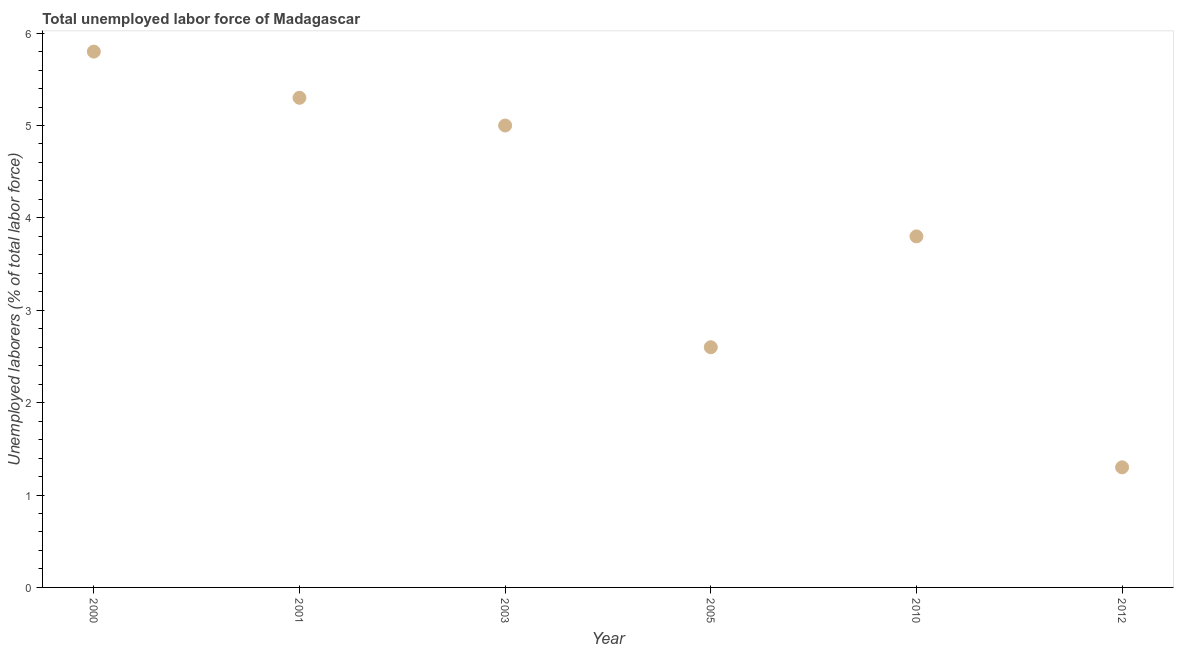What is the total unemployed labour force in 2010?
Provide a short and direct response. 3.8. Across all years, what is the maximum total unemployed labour force?
Provide a succinct answer. 5.8. Across all years, what is the minimum total unemployed labour force?
Offer a very short reply. 1.3. What is the sum of the total unemployed labour force?
Your answer should be compact. 23.8. What is the difference between the total unemployed labour force in 2000 and 2005?
Provide a succinct answer. 3.2. What is the average total unemployed labour force per year?
Keep it short and to the point. 3.97. What is the median total unemployed labour force?
Your answer should be very brief. 4.4. What is the ratio of the total unemployed labour force in 2001 to that in 2003?
Offer a very short reply. 1.06. Is the total unemployed labour force in 2000 less than that in 2003?
Provide a short and direct response. No. Is the difference between the total unemployed labour force in 2010 and 2012 greater than the difference between any two years?
Offer a very short reply. No. What is the difference between the highest and the second highest total unemployed labour force?
Your answer should be very brief. 0.5. What is the difference between the highest and the lowest total unemployed labour force?
Make the answer very short. 4.5. How many dotlines are there?
Provide a short and direct response. 1. What is the difference between two consecutive major ticks on the Y-axis?
Keep it short and to the point. 1. Does the graph contain any zero values?
Offer a terse response. No. What is the title of the graph?
Your response must be concise. Total unemployed labor force of Madagascar. What is the label or title of the Y-axis?
Ensure brevity in your answer.  Unemployed laborers (% of total labor force). What is the Unemployed laborers (% of total labor force) in 2000?
Offer a very short reply. 5.8. What is the Unemployed laborers (% of total labor force) in 2001?
Provide a succinct answer. 5.3. What is the Unemployed laborers (% of total labor force) in 2003?
Make the answer very short. 5. What is the Unemployed laborers (% of total labor force) in 2005?
Offer a very short reply. 2.6. What is the Unemployed laborers (% of total labor force) in 2010?
Ensure brevity in your answer.  3.8. What is the Unemployed laborers (% of total labor force) in 2012?
Offer a very short reply. 1.3. What is the difference between the Unemployed laborers (% of total labor force) in 2000 and 2001?
Give a very brief answer. 0.5. What is the difference between the Unemployed laborers (% of total labor force) in 2000 and 2003?
Ensure brevity in your answer.  0.8. What is the difference between the Unemployed laborers (% of total labor force) in 2000 and 2005?
Your answer should be compact. 3.2. What is the difference between the Unemployed laborers (% of total labor force) in 2000 and 2010?
Your answer should be very brief. 2. What is the difference between the Unemployed laborers (% of total labor force) in 2001 and 2003?
Provide a succinct answer. 0.3. What is the difference between the Unemployed laborers (% of total labor force) in 2001 and 2012?
Make the answer very short. 4. What is the difference between the Unemployed laborers (% of total labor force) in 2003 and 2012?
Offer a terse response. 3.7. What is the difference between the Unemployed laborers (% of total labor force) in 2005 and 2010?
Offer a very short reply. -1.2. What is the difference between the Unemployed laborers (% of total labor force) in 2005 and 2012?
Keep it short and to the point. 1.3. What is the ratio of the Unemployed laborers (% of total labor force) in 2000 to that in 2001?
Give a very brief answer. 1.09. What is the ratio of the Unemployed laborers (% of total labor force) in 2000 to that in 2003?
Offer a terse response. 1.16. What is the ratio of the Unemployed laborers (% of total labor force) in 2000 to that in 2005?
Your response must be concise. 2.23. What is the ratio of the Unemployed laborers (% of total labor force) in 2000 to that in 2010?
Offer a very short reply. 1.53. What is the ratio of the Unemployed laborers (% of total labor force) in 2000 to that in 2012?
Ensure brevity in your answer.  4.46. What is the ratio of the Unemployed laborers (% of total labor force) in 2001 to that in 2003?
Give a very brief answer. 1.06. What is the ratio of the Unemployed laborers (% of total labor force) in 2001 to that in 2005?
Offer a very short reply. 2.04. What is the ratio of the Unemployed laborers (% of total labor force) in 2001 to that in 2010?
Offer a terse response. 1.4. What is the ratio of the Unemployed laborers (% of total labor force) in 2001 to that in 2012?
Give a very brief answer. 4.08. What is the ratio of the Unemployed laborers (% of total labor force) in 2003 to that in 2005?
Give a very brief answer. 1.92. What is the ratio of the Unemployed laborers (% of total labor force) in 2003 to that in 2010?
Ensure brevity in your answer.  1.32. What is the ratio of the Unemployed laborers (% of total labor force) in 2003 to that in 2012?
Provide a short and direct response. 3.85. What is the ratio of the Unemployed laborers (% of total labor force) in 2005 to that in 2010?
Keep it short and to the point. 0.68. What is the ratio of the Unemployed laborers (% of total labor force) in 2005 to that in 2012?
Make the answer very short. 2. What is the ratio of the Unemployed laborers (% of total labor force) in 2010 to that in 2012?
Provide a short and direct response. 2.92. 